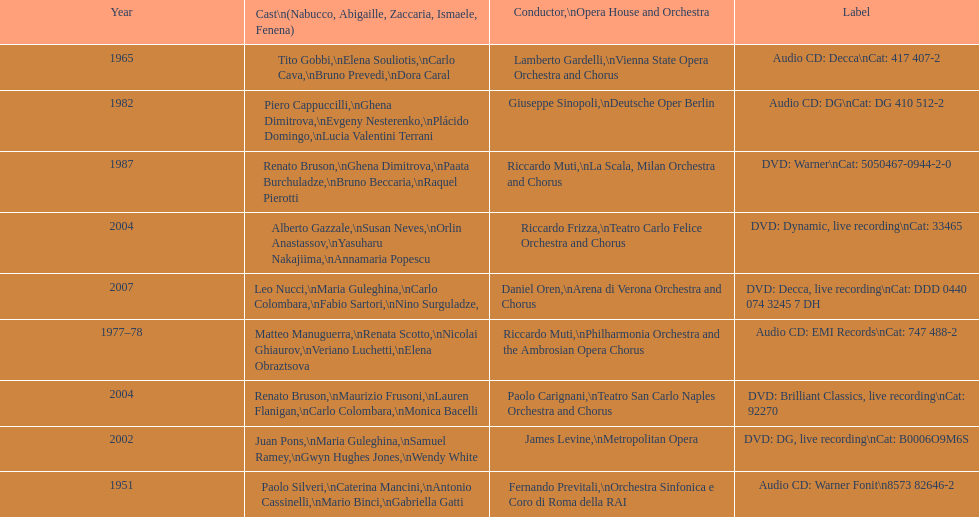How many recordings of nabucco have been made? 9. 